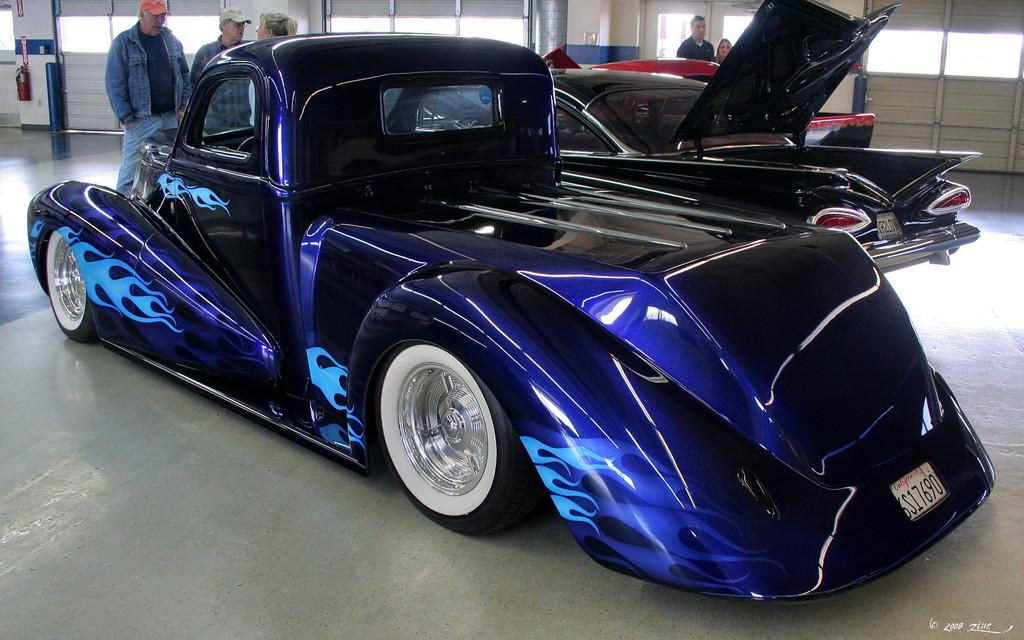What objects are on the floor in the image? There are motor vehicles on the floor. What else can be seen on the floor in the image? There are persons standing on the floor. What architectural features are present in the image? There are pillars in the image. What safety device is visible in the image? There is a fire extinguisher in the image. What type of weather can be seen in the image? There is no weather or clouds visible in the image; it is an indoor scene with motor vehicles, persons, pillars, and a fire extinguisher. 